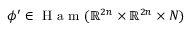<formula> <loc_0><loc_0><loc_500><loc_500>\phi ^ { \prime } \in H a m ( \mathbb { R } ^ { 2 n } \times \mathbb { R } ^ { 2 n } \times N )</formula> 